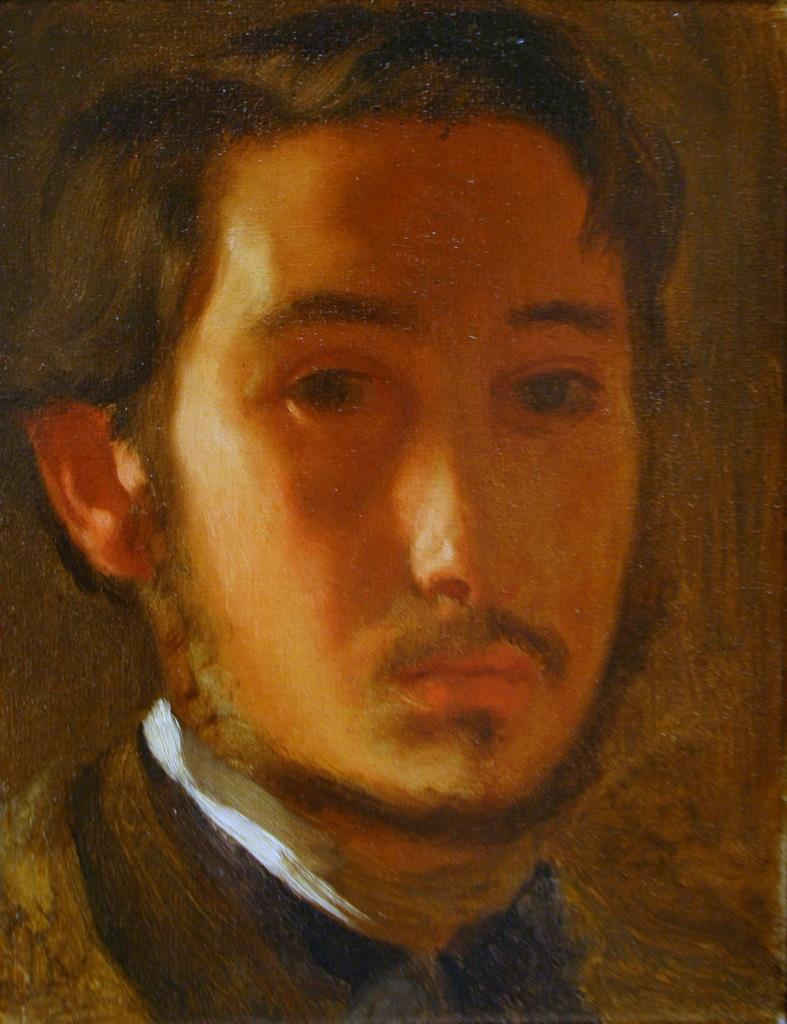What type of image is being depicted in the picture? The image is a self-portrait. Can you describe the person in the self-portrait? The person in the self-portrait is wearing a white collar. What historical event is being commemorated in the self-portrait? There is no indication of a historical event in the self-portrait; it is simply a portrait of the person wearing a white collar. Can you see a gate in the background of the self-portrait? There is no gate visible in the self-portrait; the focus is on the person wearing the white collar. 